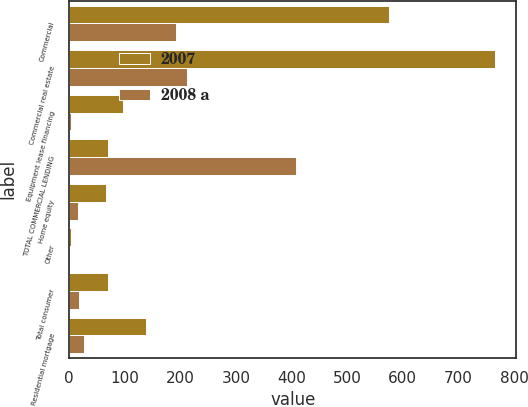Convert chart to OTSL. <chart><loc_0><loc_0><loc_500><loc_500><stacked_bar_chart><ecel><fcel>Commercial<fcel>Commercial real estate<fcel>Equipment lease financing<fcel>TOTAL COMMERCIAL LENDING<fcel>Home equity<fcel>Other<fcel>Total consumer<fcel>Residential mortgage<nl><fcel>2007<fcel>576<fcel>766<fcel>97<fcel>70<fcel>66<fcel>4<fcel>70<fcel>139<nl><fcel>2008 a<fcel>193<fcel>212<fcel>3<fcel>408<fcel>16<fcel>1<fcel>17<fcel>26<nl></chart> 